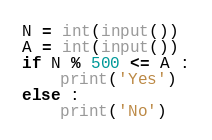Convert code to text. <code><loc_0><loc_0><loc_500><loc_500><_Python_>N = int(input())
A = int(input())
if N % 500 <= A :
    print('Yes')
else :
    print('No')</code> 